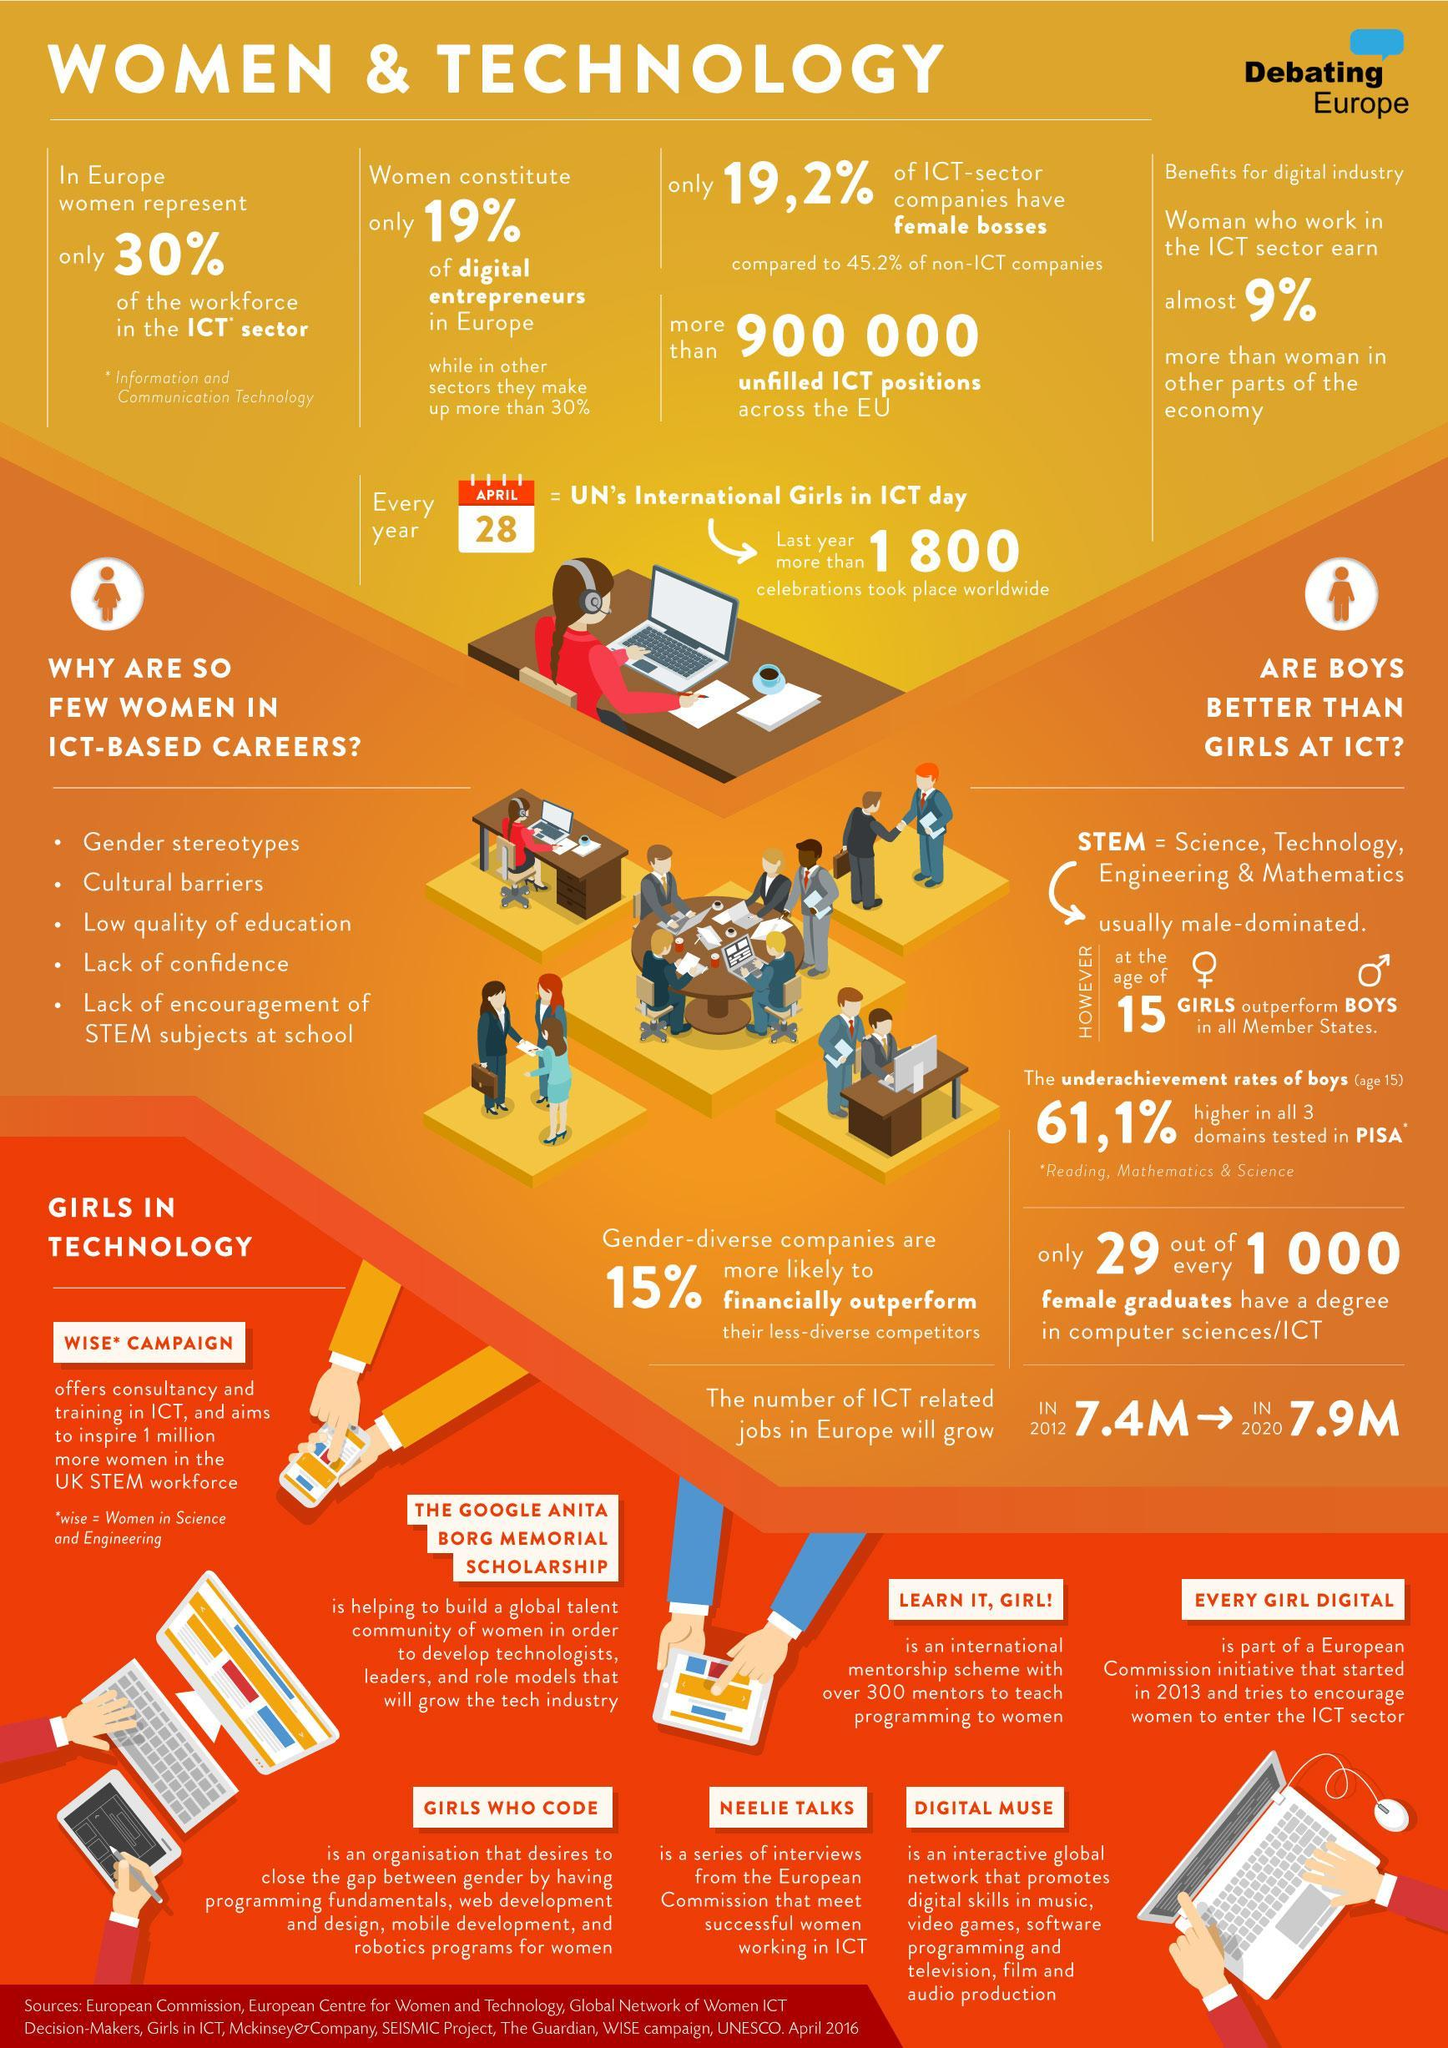What is the percentage of women entrepreneurs in Europe's digital companies, 30%, 19%, 19.2%, or 9%?
Answer the question with a short phrase. 19% 